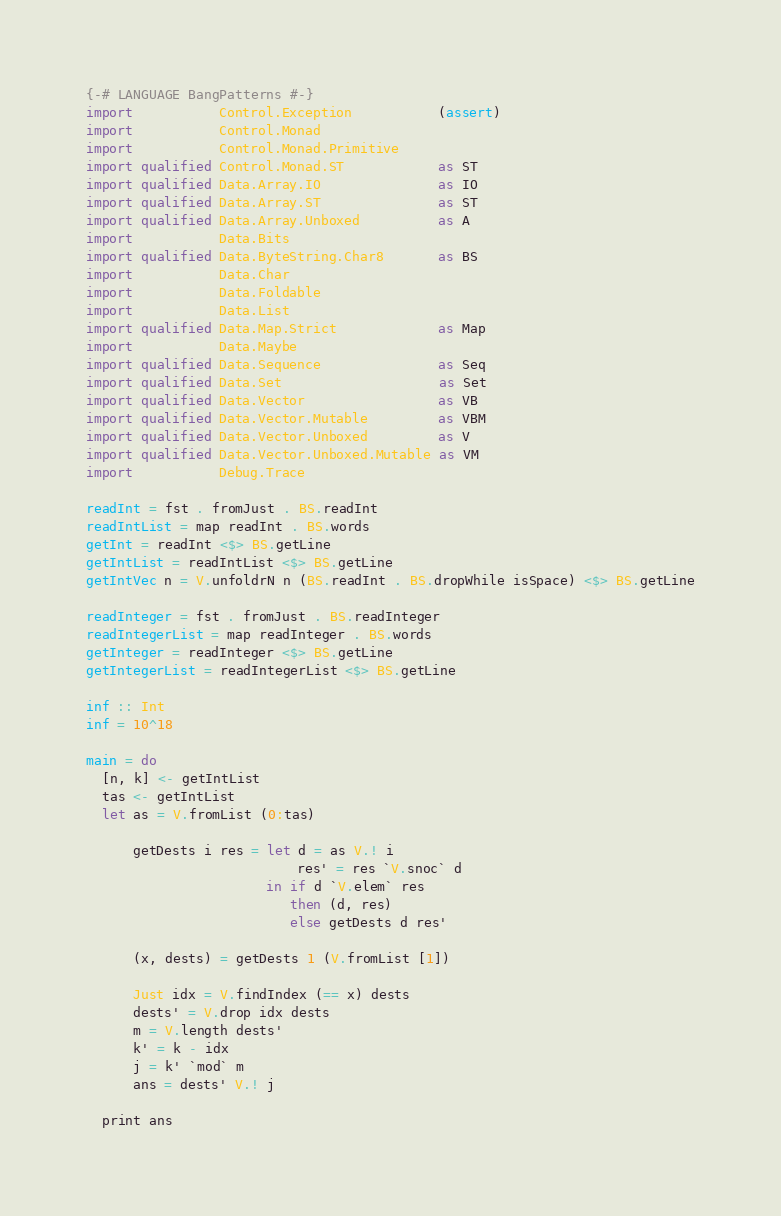Convert code to text. <code><loc_0><loc_0><loc_500><loc_500><_Haskell_>{-# LANGUAGE BangPatterns #-}
import           Control.Exception           (assert)
import           Control.Monad
import           Control.Monad.Primitive
import qualified Control.Monad.ST            as ST
import qualified Data.Array.IO               as IO
import qualified Data.Array.ST               as ST
import qualified Data.Array.Unboxed          as A
import           Data.Bits
import qualified Data.ByteString.Char8       as BS
import           Data.Char
import           Data.Foldable
import           Data.List
import qualified Data.Map.Strict             as Map
import           Data.Maybe
import qualified Data.Sequence               as Seq
import qualified Data.Set                    as Set
import qualified Data.Vector                 as VB
import qualified Data.Vector.Mutable         as VBM
import qualified Data.Vector.Unboxed         as V
import qualified Data.Vector.Unboxed.Mutable as VM
import           Debug.Trace

readInt = fst . fromJust . BS.readInt
readIntList = map readInt . BS.words
getInt = readInt <$> BS.getLine
getIntList = readIntList <$> BS.getLine
getIntVec n = V.unfoldrN n (BS.readInt . BS.dropWhile isSpace) <$> BS.getLine

readInteger = fst . fromJust . BS.readInteger
readIntegerList = map readInteger . BS.words
getInteger = readInteger <$> BS.getLine
getIntegerList = readIntegerList <$> BS.getLine

inf :: Int
inf = 10^18

main = do
  [n, k] <- getIntList
  tas <- getIntList
  let as = V.fromList (0:tas)

      getDests i res = let d = as V.! i
                           res' = res `V.snoc` d
                       in if d `V.elem` res
                          then (d, res)
                          else getDests d res'

      (x, dests) = getDests 1 (V.fromList [1])

      Just idx = V.findIndex (== x) dests
      dests' = V.drop idx dests
      m = V.length dests'
      k' = k - idx
      j = k' `mod` m
      ans = dests' V.! j

  print ans
</code> 